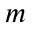Convert formula to latex. <formula><loc_0><loc_0><loc_500><loc_500>m</formula> 